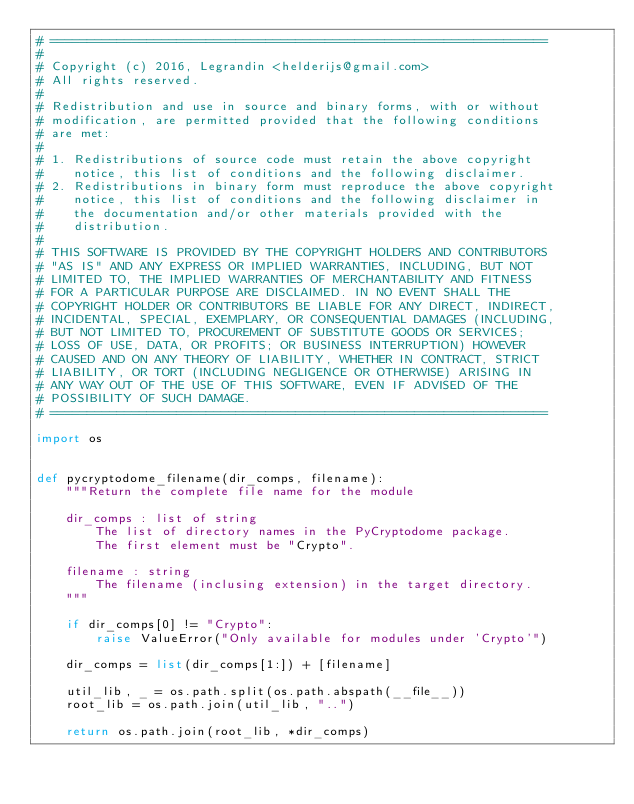Convert code to text. <code><loc_0><loc_0><loc_500><loc_500><_Python_># ===================================================================
#
# Copyright (c) 2016, Legrandin <helderijs@gmail.com>
# All rights reserved.
#
# Redistribution and use in source and binary forms, with or without
# modification, are permitted provided that the following conditions
# are met:
#
# 1. Redistributions of source code must retain the above copyright
#    notice, this list of conditions and the following disclaimer.
# 2. Redistributions in binary form must reproduce the above copyright
#    notice, this list of conditions and the following disclaimer in
#    the documentation and/or other materials provided with the
#    distribution.
#
# THIS SOFTWARE IS PROVIDED BY THE COPYRIGHT HOLDERS AND CONTRIBUTORS
# "AS IS" AND ANY EXPRESS OR IMPLIED WARRANTIES, INCLUDING, BUT NOT
# LIMITED TO, THE IMPLIED WARRANTIES OF MERCHANTABILITY AND FITNESS
# FOR A PARTICULAR PURPOSE ARE DISCLAIMED. IN NO EVENT SHALL THE
# COPYRIGHT HOLDER OR CONTRIBUTORS BE LIABLE FOR ANY DIRECT, INDIRECT,
# INCIDENTAL, SPECIAL, EXEMPLARY, OR CONSEQUENTIAL DAMAGES (INCLUDING,
# BUT NOT LIMITED TO, PROCUREMENT OF SUBSTITUTE GOODS OR SERVICES;
# LOSS OF USE, DATA, OR PROFITS; OR BUSINESS INTERRUPTION) HOWEVER
# CAUSED AND ON ANY THEORY OF LIABILITY, WHETHER IN CONTRACT, STRICT
# LIABILITY, OR TORT (INCLUDING NEGLIGENCE OR OTHERWISE) ARISING IN
# ANY WAY OUT OF THE USE OF THIS SOFTWARE, EVEN IF ADVISED OF THE
# POSSIBILITY OF SUCH DAMAGE.
# ===================================================================

import os


def pycryptodome_filename(dir_comps, filename):
    """Return the complete file name for the module

    dir_comps : list of string
        The list of directory names in the PyCryptodome package.
        The first element must be "Crypto".

    filename : string
        The filename (inclusing extension) in the target directory.
    """

    if dir_comps[0] != "Crypto":
        raise ValueError("Only available for modules under 'Crypto'")

    dir_comps = list(dir_comps[1:]) + [filename]

    util_lib, _ = os.path.split(os.path.abspath(__file__))
    root_lib = os.path.join(util_lib, "..")

    return os.path.join(root_lib, *dir_comps)

</code> 